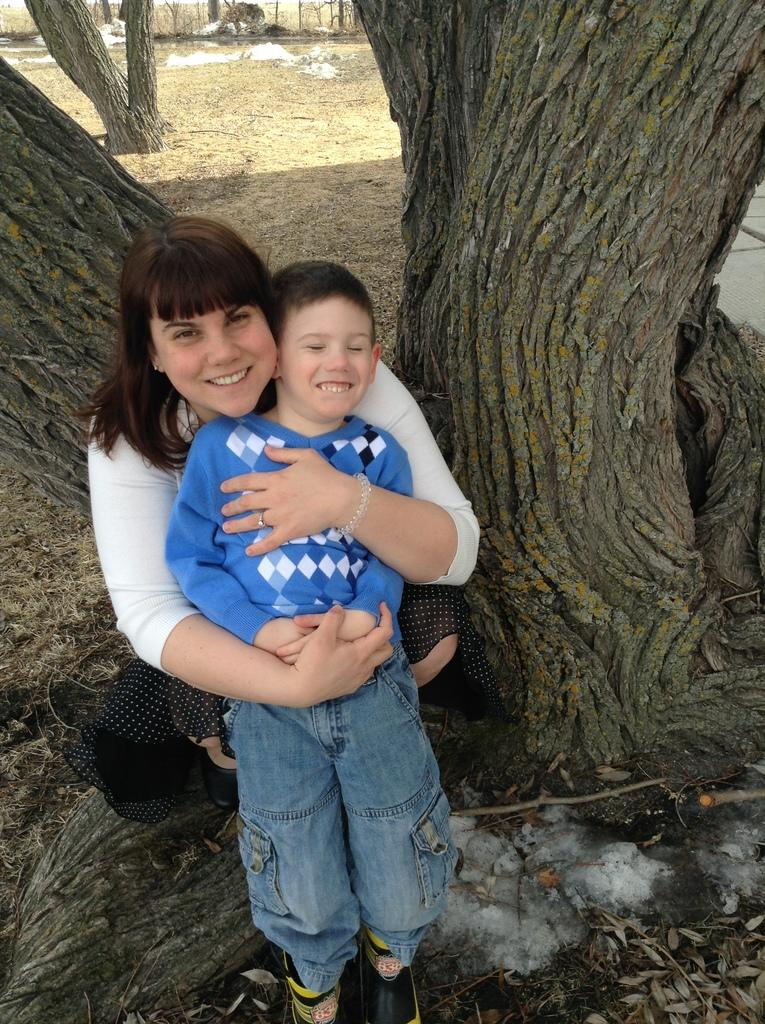How many people are in the image? There are two persons in the image. What is the person in front wearing? The person in front is wearing a blue and white color dress. What can be seen in the background of the image? There are trunks and dried plants in the background of the image. Can you see any fog in the image? There is no fog visible in the image. Is there a bike present in the image? There is no bike present in the image. 